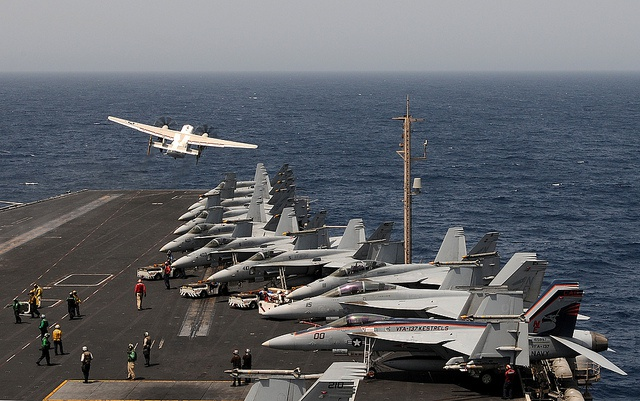Describe the objects in this image and their specific colors. I can see airplane in darkgray, black, gray, and lightgray tones, airplane in darkgray, black, gray, and lightgray tones, airplane in darkgray, black, gray, and lightgray tones, airplane in darkgray, gray, black, and lightgray tones, and airplane in darkgray, black, gray, and lightgray tones in this image. 